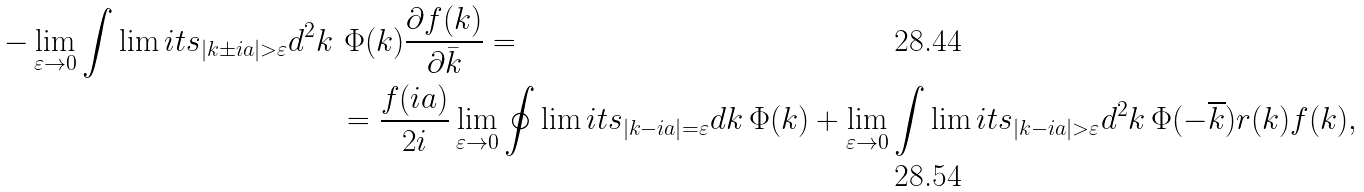Convert formula to latex. <formula><loc_0><loc_0><loc_500><loc_500>- \lim _ { \varepsilon \rightarrow 0 } \int \lim i t s _ { | k \pm i a | > \varepsilon } d ^ { 2 } k \, & \, \Phi ( k ) \frac { \partial f ( k ) } { \partial \bar { k } } = \\ & = \frac { f ( i a ) } { 2 i } \lim _ { \varepsilon \rightarrow 0 } \oint \lim i t s _ { | k - i a | = \varepsilon } d k \, \Phi ( k ) + \lim _ { \varepsilon \rightarrow 0 } \int \lim i t s _ { | k - i a | > \varepsilon } d ^ { 2 } k \, \Phi ( - \overline { k } ) r ( k ) f ( k ) ,</formula> 